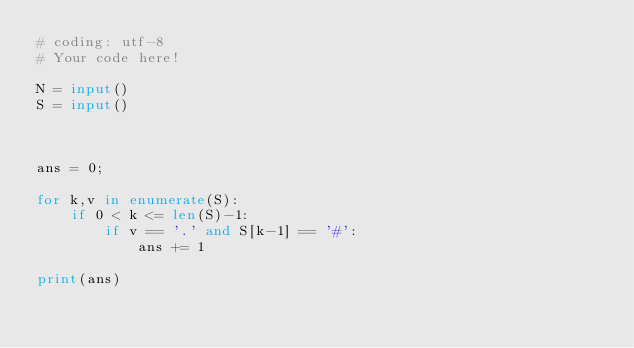Convert code to text. <code><loc_0><loc_0><loc_500><loc_500><_Python_># coding: utf-8
# Your code here!

N = input()
S = input()



ans = 0;

for k,v in enumerate(S):
    if 0 < k <= len(S)-1:
        if v == '.' and S[k-1] == '#':
            ans += 1
    
print(ans)</code> 